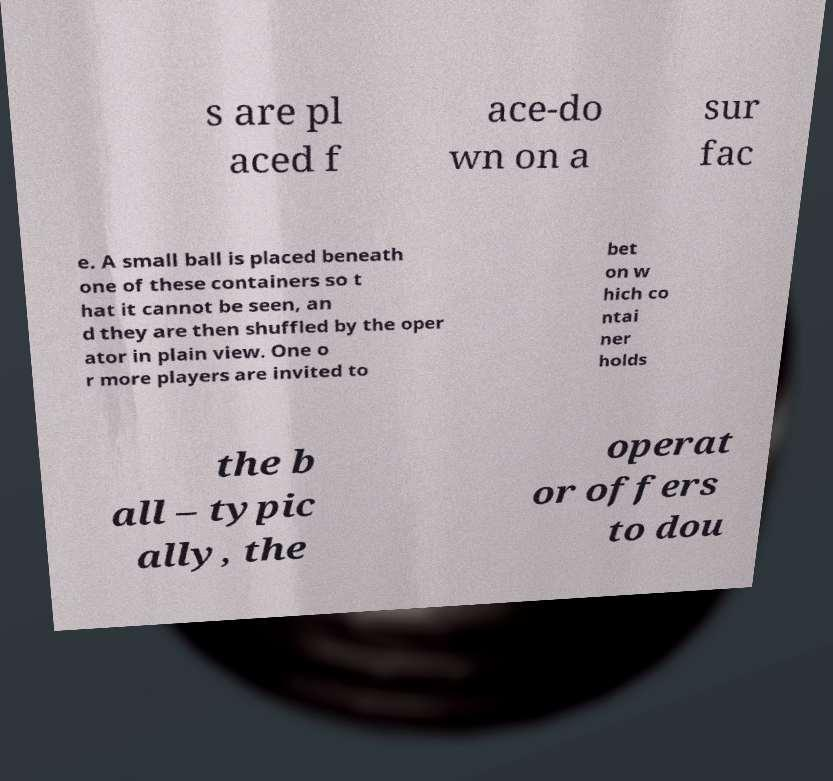Please identify and transcribe the text found in this image. s are pl aced f ace-do wn on a sur fac e. A small ball is placed beneath one of these containers so t hat it cannot be seen, an d they are then shuffled by the oper ator in plain view. One o r more players are invited to bet on w hich co ntai ner holds the b all – typic ally, the operat or offers to dou 